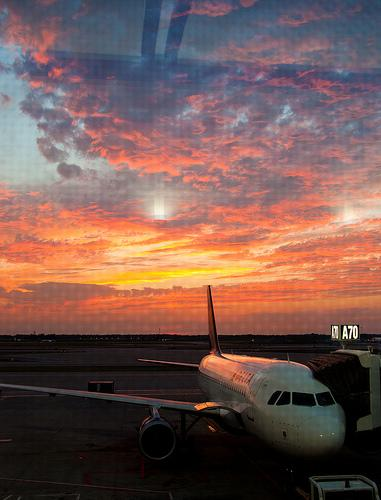Describe the sky in the image. The sky showcases a picturesque and unique sunset with a mix of red, orange, yellow, purple, and grey clouds. In one sentence, describe the overall atmosphere of the image. A serene airport scene with a white Delta airplane parked on the runway, amidst the stunning canvas of a colorful, cloudy sunset. In a poetic way, describe the image. A majestic white airplane sits on the runway, basking in the glory of a captivating sunset painting the sky with vibrant hues of red, orange, and purple. Mention the most significant aspects of the image. A Delta airplane parked in an airport, a sky with a stunning mix of clouds and colors, and an A70 terminal sign. Point out the distinctive characteristics of the airplane in the image. The airplane is a large white Delta jet with long wings, a windshield, many windows, and a well-lit engine on its wing. Mention the main elements present in the image and their location. A white airplane is parked in an airport with a lighted terminal a70 sign nearby, blue lights on the runway, and a cloudy red, orange, and gray sky creates a beautiful sunset backdrop. Briefly describe the image focusing on the airplane. A Delta airplane with its engines, wings, and tail is parked in an airport, while the sign of a70 is visible and the sky displays a colorful sunset. Describe the image focusing on the sunset. An awe-inspiring sunset with a myriad of colors, including red, orange, yellow, and purple, illuminates the sky, providing a visually captivating backdrop for the parked Delta airplane. List the main colors present in the image. White, red, orange, yellow, purple, gray, and blue. Briefly explain the setting where the airplane is parked. The airplane is parked on a runway at an airport, with blue runway lights, an A70 terminal sign, and a luggage cart seen nearby. 